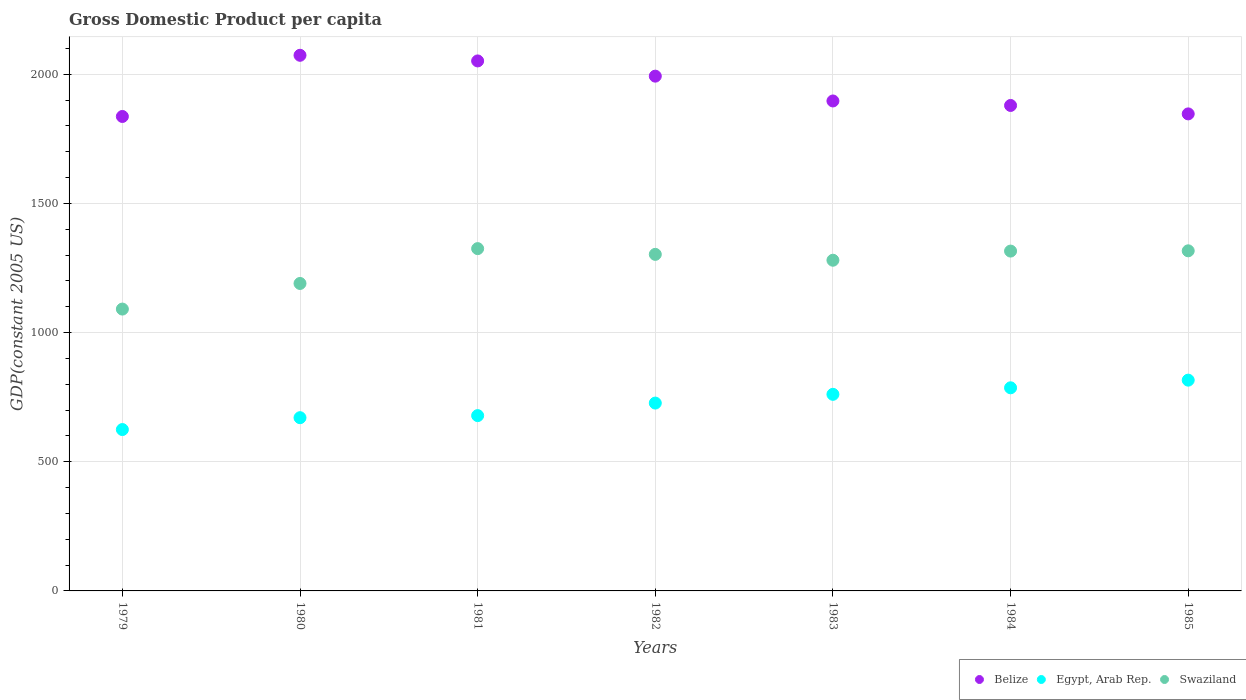How many different coloured dotlines are there?
Your answer should be very brief. 3. What is the GDP per capita in Belize in 1983?
Offer a very short reply. 1896.53. Across all years, what is the maximum GDP per capita in Swaziland?
Give a very brief answer. 1324.99. Across all years, what is the minimum GDP per capita in Egypt, Arab Rep.?
Offer a terse response. 624.63. In which year was the GDP per capita in Swaziland minimum?
Provide a short and direct response. 1979. What is the total GDP per capita in Swaziland in the graph?
Offer a terse response. 8820.86. What is the difference between the GDP per capita in Belize in 1979 and that in 1982?
Make the answer very short. -156.08. What is the difference between the GDP per capita in Swaziland in 1984 and the GDP per capita in Egypt, Arab Rep. in 1979?
Make the answer very short. 690.82. What is the average GDP per capita in Swaziland per year?
Offer a terse response. 1260.12. In the year 1980, what is the difference between the GDP per capita in Belize and GDP per capita in Egypt, Arab Rep.?
Give a very brief answer. 1402.78. What is the ratio of the GDP per capita in Egypt, Arab Rep. in 1980 to that in 1982?
Offer a very short reply. 0.92. Is the GDP per capita in Swaziland in 1982 less than that in 1983?
Make the answer very short. No. What is the difference between the highest and the second highest GDP per capita in Egypt, Arab Rep.?
Keep it short and to the point. 29.63. What is the difference between the highest and the lowest GDP per capita in Swaziland?
Offer a very short reply. 234. Is it the case that in every year, the sum of the GDP per capita in Swaziland and GDP per capita in Belize  is greater than the GDP per capita in Egypt, Arab Rep.?
Provide a short and direct response. Yes. Is the GDP per capita in Egypt, Arab Rep. strictly greater than the GDP per capita in Belize over the years?
Give a very brief answer. No. How many dotlines are there?
Your answer should be very brief. 3. How many years are there in the graph?
Keep it short and to the point. 7. What is the difference between two consecutive major ticks on the Y-axis?
Your answer should be very brief. 500. Are the values on the major ticks of Y-axis written in scientific E-notation?
Offer a terse response. No. Does the graph contain any zero values?
Make the answer very short. No. Does the graph contain grids?
Keep it short and to the point. Yes. How many legend labels are there?
Your answer should be very brief. 3. What is the title of the graph?
Keep it short and to the point. Gross Domestic Product per capita. Does "Papua New Guinea" appear as one of the legend labels in the graph?
Give a very brief answer. No. What is the label or title of the Y-axis?
Your answer should be compact. GDP(constant 2005 US). What is the GDP(constant 2005 US) in Belize in 1979?
Keep it short and to the point. 1836.53. What is the GDP(constant 2005 US) of Egypt, Arab Rep. in 1979?
Keep it short and to the point. 624.63. What is the GDP(constant 2005 US) in Swaziland in 1979?
Your response must be concise. 1090.99. What is the GDP(constant 2005 US) in Belize in 1980?
Your answer should be very brief. 2073.35. What is the GDP(constant 2005 US) of Egypt, Arab Rep. in 1980?
Your answer should be very brief. 670.57. What is the GDP(constant 2005 US) of Swaziland in 1980?
Offer a terse response. 1190.14. What is the GDP(constant 2005 US) in Belize in 1981?
Your response must be concise. 2051.51. What is the GDP(constant 2005 US) in Egypt, Arab Rep. in 1981?
Your answer should be very brief. 678.6. What is the GDP(constant 2005 US) of Swaziland in 1981?
Your answer should be compact. 1324.99. What is the GDP(constant 2005 US) of Belize in 1982?
Offer a terse response. 1992.6. What is the GDP(constant 2005 US) of Egypt, Arab Rep. in 1982?
Offer a very short reply. 727.11. What is the GDP(constant 2005 US) in Swaziland in 1982?
Your answer should be very brief. 1302.75. What is the GDP(constant 2005 US) in Belize in 1983?
Give a very brief answer. 1896.53. What is the GDP(constant 2005 US) in Egypt, Arab Rep. in 1983?
Ensure brevity in your answer.  760.96. What is the GDP(constant 2005 US) in Swaziland in 1983?
Keep it short and to the point. 1280.04. What is the GDP(constant 2005 US) of Belize in 1984?
Provide a short and direct response. 1879.13. What is the GDP(constant 2005 US) in Egypt, Arab Rep. in 1984?
Your answer should be compact. 786.24. What is the GDP(constant 2005 US) of Swaziland in 1984?
Keep it short and to the point. 1315.45. What is the GDP(constant 2005 US) in Belize in 1985?
Your response must be concise. 1846.51. What is the GDP(constant 2005 US) in Egypt, Arab Rep. in 1985?
Your answer should be compact. 815.88. What is the GDP(constant 2005 US) of Swaziland in 1985?
Make the answer very short. 1316.5. Across all years, what is the maximum GDP(constant 2005 US) in Belize?
Your answer should be compact. 2073.35. Across all years, what is the maximum GDP(constant 2005 US) in Egypt, Arab Rep.?
Your response must be concise. 815.88. Across all years, what is the maximum GDP(constant 2005 US) of Swaziland?
Your answer should be very brief. 1324.99. Across all years, what is the minimum GDP(constant 2005 US) of Belize?
Offer a very short reply. 1836.53. Across all years, what is the minimum GDP(constant 2005 US) of Egypt, Arab Rep.?
Provide a short and direct response. 624.63. Across all years, what is the minimum GDP(constant 2005 US) in Swaziland?
Offer a very short reply. 1090.99. What is the total GDP(constant 2005 US) of Belize in the graph?
Your answer should be very brief. 1.36e+04. What is the total GDP(constant 2005 US) in Egypt, Arab Rep. in the graph?
Give a very brief answer. 5063.99. What is the total GDP(constant 2005 US) of Swaziland in the graph?
Your response must be concise. 8820.86. What is the difference between the GDP(constant 2005 US) in Belize in 1979 and that in 1980?
Make the answer very short. -236.82. What is the difference between the GDP(constant 2005 US) in Egypt, Arab Rep. in 1979 and that in 1980?
Make the answer very short. -45.93. What is the difference between the GDP(constant 2005 US) in Swaziland in 1979 and that in 1980?
Offer a terse response. -99.14. What is the difference between the GDP(constant 2005 US) of Belize in 1979 and that in 1981?
Your answer should be very brief. -214.98. What is the difference between the GDP(constant 2005 US) of Egypt, Arab Rep. in 1979 and that in 1981?
Ensure brevity in your answer.  -53.96. What is the difference between the GDP(constant 2005 US) of Swaziland in 1979 and that in 1981?
Offer a very short reply. -234. What is the difference between the GDP(constant 2005 US) in Belize in 1979 and that in 1982?
Offer a very short reply. -156.08. What is the difference between the GDP(constant 2005 US) of Egypt, Arab Rep. in 1979 and that in 1982?
Give a very brief answer. -102.48. What is the difference between the GDP(constant 2005 US) of Swaziland in 1979 and that in 1982?
Offer a terse response. -211.75. What is the difference between the GDP(constant 2005 US) in Belize in 1979 and that in 1983?
Offer a very short reply. -60.01. What is the difference between the GDP(constant 2005 US) of Egypt, Arab Rep. in 1979 and that in 1983?
Provide a short and direct response. -136.33. What is the difference between the GDP(constant 2005 US) of Swaziland in 1979 and that in 1983?
Make the answer very short. -189.05. What is the difference between the GDP(constant 2005 US) of Belize in 1979 and that in 1984?
Your answer should be compact. -42.61. What is the difference between the GDP(constant 2005 US) of Egypt, Arab Rep. in 1979 and that in 1984?
Ensure brevity in your answer.  -161.61. What is the difference between the GDP(constant 2005 US) in Swaziland in 1979 and that in 1984?
Provide a short and direct response. -224.46. What is the difference between the GDP(constant 2005 US) in Belize in 1979 and that in 1985?
Provide a short and direct response. -9.98. What is the difference between the GDP(constant 2005 US) of Egypt, Arab Rep. in 1979 and that in 1985?
Give a very brief answer. -191.24. What is the difference between the GDP(constant 2005 US) in Swaziland in 1979 and that in 1985?
Give a very brief answer. -225.5. What is the difference between the GDP(constant 2005 US) of Belize in 1980 and that in 1981?
Make the answer very short. 21.84. What is the difference between the GDP(constant 2005 US) of Egypt, Arab Rep. in 1980 and that in 1981?
Provide a short and direct response. -8.03. What is the difference between the GDP(constant 2005 US) of Swaziland in 1980 and that in 1981?
Offer a very short reply. -134.86. What is the difference between the GDP(constant 2005 US) of Belize in 1980 and that in 1982?
Give a very brief answer. 80.74. What is the difference between the GDP(constant 2005 US) in Egypt, Arab Rep. in 1980 and that in 1982?
Offer a very short reply. -56.55. What is the difference between the GDP(constant 2005 US) in Swaziland in 1980 and that in 1982?
Keep it short and to the point. -112.61. What is the difference between the GDP(constant 2005 US) in Belize in 1980 and that in 1983?
Offer a very short reply. 176.81. What is the difference between the GDP(constant 2005 US) in Egypt, Arab Rep. in 1980 and that in 1983?
Make the answer very short. -90.39. What is the difference between the GDP(constant 2005 US) in Swaziland in 1980 and that in 1983?
Make the answer very short. -89.91. What is the difference between the GDP(constant 2005 US) in Belize in 1980 and that in 1984?
Offer a very short reply. 194.22. What is the difference between the GDP(constant 2005 US) of Egypt, Arab Rep. in 1980 and that in 1984?
Your response must be concise. -115.68. What is the difference between the GDP(constant 2005 US) of Swaziland in 1980 and that in 1984?
Your response must be concise. -125.32. What is the difference between the GDP(constant 2005 US) of Belize in 1980 and that in 1985?
Your answer should be very brief. 226.84. What is the difference between the GDP(constant 2005 US) in Egypt, Arab Rep. in 1980 and that in 1985?
Your answer should be compact. -145.31. What is the difference between the GDP(constant 2005 US) in Swaziland in 1980 and that in 1985?
Give a very brief answer. -126.36. What is the difference between the GDP(constant 2005 US) of Belize in 1981 and that in 1982?
Offer a terse response. 58.9. What is the difference between the GDP(constant 2005 US) of Egypt, Arab Rep. in 1981 and that in 1982?
Your response must be concise. -48.51. What is the difference between the GDP(constant 2005 US) of Swaziland in 1981 and that in 1982?
Make the answer very short. 22.25. What is the difference between the GDP(constant 2005 US) of Belize in 1981 and that in 1983?
Give a very brief answer. 154.97. What is the difference between the GDP(constant 2005 US) of Egypt, Arab Rep. in 1981 and that in 1983?
Give a very brief answer. -82.36. What is the difference between the GDP(constant 2005 US) in Swaziland in 1981 and that in 1983?
Offer a very short reply. 44.95. What is the difference between the GDP(constant 2005 US) of Belize in 1981 and that in 1984?
Offer a very short reply. 172.37. What is the difference between the GDP(constant 2005 US) in Egypt, Arab Rep. in 1981 and that in 1984?
Provide a succinct answer. -107.65. What is the difference between the GDP(constant 2005 US) of Swaziland in 1981 and that in 1984?
Keep it short and to the point. 9.54. What is the difference between the GDP(constant 2005 US) of Belize in 1981 and that in 1985?
Your response must be concise. 205. What is the difference between the GDP(constant 2005 US) in Egypt, Arab Rep. in 1981 and that in 1985?
Your answer should be very brief. -137.28. What is the difference between the GDP(constant 2005 US) of Swaziland in 1981 and that in 1985?
Your answer should be very brief. 8.5. What is the difference between the GDP(constant 2005 US) in Belize in 1982 and that in 1983?
Give a very brief answer. 96.07. What is the difference between the GDP(constant 2005 US) of Egypt, Arab Rep. in 1982 and that in 1983?
Offer a very short reply. -33.85. What is the difference between the GDP(constant 2005 US) of Swaziland in 1982 and that in 1983?
Offer a very short reply. 22.7. What is the difference between the GDP(constant 2005 US) in Belize in 1982 and that in 1984?
Your answer should be compact. 113.47. What is the difference between the GDP(constant 2005 US) in Egypt, Arab Rep. in 1982 and that in 1984?
Provide a short and direct response. -59.13. What is the difference between the GDP(constant 2005 US) in Swaziland in 1982 and that in 1984?
Offer a very short reply. -12.71. What is the difference between the GDP(constant 2005 US) of Belize in 1982 and that in 1985?
Provide a succinct answer. 146.1. What is the difference between the GDP(constant 2005 US) in Egypt, Arab Rep. in 1982 and that in 1985?
Offer a terse response. -88.76. What is the difference between the GDP(constant 2005 US) in Swaziland in 1982 and that in 1985?
Keep it short and to the point. -13.75. What is the difference between the GDP(constant 2005 US) of Belize in 1983 and that in 1984?
Your answer should be very brief. 17.4. What is the difference between the GDP(constant 2005 US) of Egypt, Arab Rep. in 1983 and that in 1984?
Make the answer very short. -25.28. What is the difference between the GDP(constant 2005 US) of Swaziland in 1983 and that in 1984?
Your answer should be very brief. -35.41. What is the difference between the GDP(constant 2005 US) in Belize in 1983 and that in 1985?
Provide a short and direct response. 50.03. What is the difference between the GDP(constant 2005 US) of Egypt, Arab Rep. in 1983 and that in 1985?
Your answer should be very brief. -54.92. What is the difference between the GDP(constant 2005 US) of Swaziland in 1983 and that in 1985?
Offer a very short reply. -36.45. What is the difference between the GDP(constant 2005 US) in Belize in 1984 and that in 1985?
Ensure brevity in your answer.  32.63. What is the difference between the GDP(constant 2005 US) in Egypt, Arab Rep. in 1984 and that in 1985?
Your answer should be very brief. -29.63. What is the difference between the GDP(constant 2005 US) in Swaziland in 1984 and that in 1985?
Offer a very short reply. -1.04. What is the difference between the GDP(constant 2005 US) in Belize in 1979 and the GDP(constant 2005 US) in Egypt, Arab Rep. in 1980?
Offer a terse response. 1165.96. What is the difference between the GDP(constant 2005 US) of Belize in 1979 and the GDP(constant 2005 US) of Swaziland in 1980?
Keep it short and to the point. 646.39. What is the difference between the GDP(constant 2005 US) in Egypt, Arab Rep. in 1979 and the GDP(constant 2005 US) in Swaziland in 1980?
Keep it short and to the point. -565.5. What is the difference between the GDP(constant 2005 US) of Belize in 1979 and the GDP(constant 2005 US) of Egypt, Arab Rep. in 1981?
Your response must be concise. 1157.93. What is the difference between the GDP(constant 2005 US) of Belize in 1979 and the GDP(constant 2005 US) of Swaziland in 1981?
Offer a terse response. 511.53. What is the difference between the GDP(constant 2005 US) in Egypt, Arab Rep. in 1979 and the GDP(constant 2005 US) in Swaziland in 1981?
Your answer should be compact. -700.36. What is the difference between the GDP(constant 2005 US) in Belize in 1979 and the GDP(constant 2005 US) in Egypt, Arab Rep. in 1982?
Provide a short and direct response. 1109.41. What is the difference between the GDP(constant 2005 US) of Belize in 1979 and the GDP(constant 2005 US) of Swaziland in 1982?
Provide a short and direct response. 533.78. What is the difference between the GDP(constant 2005 US) in Egypt, Arab Rep. in 1979 and the GDP(constant 2005 US) in Swaziland in 1982?
Provide a short and direct response. -678.11. What is the difference between the GDP(constant 2005 US) of Belize in 1979 and the GDP(constant 2005 US) of Egypt, Arab Rep. in 1983?
Offer a very short reply. 1075.57. What is the difference between the GDP(constant 2005 US) in Belize in 1979 and the GDP(constant 2005 US) in Swaziland in 1983?
Offer a very short reply. 556.48. What is the difference between the GDP(constant 2005 US) of Egypt, Arab Rep. in 1979 and the GDP(constant 2005 US) of Swaziland in 1983?
Offer a very short reply. -655.41. What is the difference between the GDP(constant 2005 US) of Belize in 1979 and the GDP(constant 2005 US) of Egypt, Arab Rep. in 1984?
Offer a very short reply. 1050.28. What is the difference between the GDP(constant 2005 US) in Belize in 1979 and the GDP(constant 2005 US) in Swaziland in 1984?
Offer a terse response. 521.07. What is the difference between the GDP(constant 2005 US) of Egypt, Arab Rep. in 1979 and the GDP(constant 2005 US) of Swaziland in 1984?
Provide a short and direct response. -690.82. What is the difference between the GDP(constant 2005 US) of Belize in 1979 and the GDP(constant 2005 US) of Egypt, Arab Rep. in 1985?
Keep it short and to the point. 1020.65. What is the difference between the GDP(constant 2005 US) in Belize in 1979 and the GDP(constant 2005 US) in Swaziland in 1985?
Give a very brief answer. 520.03. What is the difference between the GDP(constant 2005 US) in Egypt, Arab Rep. in 1979 and the GDP(constant 2005 US) in Swaziland in 1985?
Give a very brief answer. -691.86. What is the difference between the GDP(constant 2005 US) of Belize in 1980 and the GDP(constant 2005 US) of Egypt, Arab Rep. in 1981?
Your response must be concise. 1394.75. What is the difference between the GDP(constant 2005 US) of Belize in 1980 and the GDP(constant 2005 US) of Swaziland in 1981?
Provide a short and direct response. 748.36. What is the difference between the GDP(constant 2005 US) of Egypt, Arab Rep. in 1980 and the GDP(constant 2005 US) of Swaziland in 1981?
Your answer should be very brief. -654.43. What is the difference between the GDP(constant 2005 US) in Belize in 1980 and the GDP(constant 2005 US) in Egypt, Arab Rep. in 1982?
Keep it short and to the point. 1346.24. What is the difference between the GDP(constant 2005 US) in Belize in 1980 and the GDP(constant 2005 US) in Swaziland in 1982?
Provide a succinct answer. 770.6. What is the difference between the GDP(constant 2005 US) of Egypt, Arab Rep. in 1980 and the GDP(constant 2005 US) of Swaziland in 1982?
Provide a short and direct response. -632.18. What is the difference between the GDP(constant 2005 US) in Belize in 1980 and the GDP(constant 2005 US) in Egypt, Arab Rep. in 1983?
Your answer should be very brief. 1312.39. What is the difference between the GDP(constant 2005 US) of Belize in 1980 and the GDP(constant 2005 US) of Swaziland in 1983?
Your answer should be compact. 793.31. What is the difference between the GDP(constant 2005 US) in Egypt, Arab Rep. in 1980 and the GDP(constant 2005 US) in Swaziland in 1983?
Provide a short and direct response. -609.48. What is the difference between the GDP(constant 2005 US) in Belize in 1980 and the GDP(constant 2005 US) in Egypt, Arab Rep. in 1984?
Ensure brevity in your answer.  1287.11. What is the difference between the GDP(constant 2005 US) in Belize in 1980 and the GDP(constant 2005 US) in Swaziland in 1984?
Give a very brief answer. 757.9. What is the difference between the GDP(constant 2005 US) of Egypt, Arab Rep. in 1980 and the GDP(constant 2005 US) of Swaziland in 1984?
Offer a very short reply. -644.89. What is the difference between the GDP(constant 2005 US) of Belize in 1980 and the GDP(constant 2005 US) of Egypt, Arab Rep. in 1985?
Ensure brevity in your answer.  1257.47. What is the difference between the GDP(constant 2005 US) of Belize in 1980 and the GDP(constant 2005 US) of Swaziland in 1985?
Your answer should be compact. 756.85. What is the difference between the GDP(constant 2005 US) in Egypt, Arab Rep. in 1980 and the GDP(constant 2005 US) in Swaziland in 1985?
Provide a short and direct response. -645.93. What is the difference between the GDP(constant 2005 US) in Belize in 1981 and the GDP(constant 2005 US) in Egypt, Arab Rep. in 1982?
Make the answer very short. 1324.4. What is the difference between the GDP(constant 2005 US) in Belize in 1981 and the GDP(constant 2005 US) in Swaziland in 1982?
Provide a succinct answer. 748.76. What is the difference between the GDP(constant 2005 US) of Egypt, Arab Rep. in 1981 and the GDP(constant 2005 US) of Swaziland in 1982?
Provide a short and direct response. -624.15. What is the difference between the GDP(constant 2005 US) of Belize in 1981 and the GDP(constant 2005 US) of Egypt, Arab Rep. in 1983?
Ensure brevity in your answer.  1290.55. What is the difference between the GDP(constant 2005 US) of Belize in 1981 and the GDP(constant 2005 US) of Swaziland in 1983?
Your response must be concise. 771.46. What is the difference between the GDP(constant 2005 US) of Egypt, Arab Rep. in 1981 and the GDP(constant 2005 US) of Swaziland in 1983?
Give a very brief answer. -601.45. What is the difference between the GDP(constant 2005 US) in Belize in 1981 and the GDP(constant 2005 US) in Egypt, Arab Rep. in 1984?
Give a very brief answer. 1265.26. What is the difference between the GDP(constant 2005 US) of Belize in 1981 and the GDP(constant 2005 US) of Swaziland in 1984?
Offer a very short reply. 736.05. What is the difference between the GDP(constant 2005 US) in Egypt, Arab Rep. in 1981 and the GDP(constant 2005 US) in Swaziland in 1984?
Make the answer very short. -636.86. What is the difference between the GDP(constant 2005 US) of Belize in 1981 and the GDP(constant 2005 US) of Egypt, Arab Rep. in 1985?
Provide a short and direct response. 1235.63. What is the difference between the GDP(constant 2005 US) in Belize in 1981 and the GDP(constant 2005 US) in Swaziland in 1985?
Make the answer very short. 735.01. What is the difference between the GDP(constant 2005 US) of Egypt, Arab Rep. in 1981 and the GDP(constant 2005 US) of Swaziland in 1985?
Offer a terse response. -637.9. What is the difference between the GDP(constant 2005 US) in Belize in 1982 and the GDP(constant 2005 US) in Egypt, Arab Rep. in 1983?
Make the answer very short. 1231.64. What is the difference between the GDP(constant 2005 US) of Belize in 1982 and the GDP(constant 2005 US) of Swaziland in 1983?
Offer a terse response. 712.56. What is the difference between the GDP(constant 2005 US) in Egypt, Arab Rep. in 1982 and the GDP(constant 2005 US) in Swaziland in 1983?
Keep it short and to the point. -552.93. What is the difference between the GDP(constant 2005 US) in Belize in 1982 and the GDP(constant 2005 US) in Egypt, Arab Rep. in 1984?
Offer a very short reply. 1206.36. What is the difference between the GDP(constant 2005 US) of Belize in 1982 and the GDP(constant 2005 US) of Swaziland in 1984?
Ensure brevity in your answer.  677.15. What is the difference between the GDP(constant 2005 US) in Egypt, Arab Rep. in 1982 and the GDP(constant 2005 US) in Swaziland in 1984?
Provide a succinct answer. -588.34. What is the difference between the GDP(constant 2005 US) of Belize in 1982 and the GDP(constant 2005 US) of Egypt, Arab Rep. in 1985?
Keep it short and to the point. 1176.73. What is the difference between the GDP(constant 2005 US) in Belize in 1982 and the GDP(constant 2005 US) in Swaziland in 1985?
Make the answer very short. 676.11. What is the difference between the GDP(constant 2005 US) in Egypt, Arab Rep. in 1982 and the GDP(constant 2005 US) in Swaziland in 1985?
Give a very brief answer. -589.38. What is the difference between the GDP(constant 2005 US) in Belize in 1983 and the GDP(constant 2005 US) in Egypt, Arab Rep. in 1984?
Your answer should be very brief. 1110.29. What is the difference between the GDP(constant 2005 US) in Belize in 1983 and the GDP(constant 2005 US) in Swaziland in 1984?
Provide a succinct answer. 581.08. What is the difference between the GDP(constant 2005 US) in Egypt, Arab Rep. in 1983 and the GDP(constant 2005 US) in Swaziland in 1984?
Provide a succinct answer. -554.49. What is the difference between the GDP(constant 2005 US) of Belize in 1983 and the GDP(constant 2005 US) of Egypt, Arab Rep. in 1985?
Your response must be concise. 1080.66. What is the difference between the GDP(constant 2005 US) of Belize in 1983 and the GDP(constant 2005 US) of Swaziland in 1985?
Make the answer very short. 580.04. What is the difference between the GDP(constant 2005 US) of Egypt, Arab Rep. in 1983 and the GDP(constant 2005 US) of Swaziland in 1985?
Keep it short and to the point. -555.54. What is the difference between the GDP(constant 2005 US) in Belize in 1984 and the GDP(constant 2005 US) in Egypt, Arab Rep. in 1985?
Offer a terse response. 1063.26. What is the difference between the GDP(constant 2005 US) of Belize in 1984 and the GDP(constant 2005 US) of Swaziland in 1985?
Ensure brevity in your answer.  562.64. What is the difference between the GDP(constant 2005 US) of Egypt, Arab Rep. in 1984 and the GDP(constant 2005 US) of Swaziland in 1985?
Your answer should be compact. -530.25. What is the average GDP(constant 2005 US) of Belize per year?
Provide a succinct answer. 1939.45. What is the average GDP(constant 2005 US) of Egypt, Arab Rep. per year?
Provide a short and direct response. 723.43. What is the average GDP(constant 2005 US) in Swaziland per year?
Provide a succinct answer. 1260.12. In the year 1979, what is the difference between the GDP(constant 2005 US) in Belize and GDP(constant 2005 US) in Egypt, Arab Rep.?
Offer a very short reply. 1211.89. In the year 1979, what is the difference between the GDP(constant 2005 US) of Belize and GDP(constant 2005 US) of Swaziland?
Offer a terse response. 745.53. In the year 1979, what is the difference between the GDP(constant 2005 US) in Egypt, Arab Rep. and GDP(constant 2005 US) in Swaziland?
Provide a succinct answer. -466.36. In the year 1980, what is the difference between the GDP(constant 2005 US) of Belize and GDP(constant 2005 US) of Egypt, Arab Rep.?
Make the answer very short. 1402.78. In the year 1980, what is the difference between the GDP(constant 2005 US) in Belize and GDP(constant 2005 US) in Swaziland?
Make the answer very short. 883.21. In the year 1980, what is the difference between the GDP(constant 2005 US) in Egypt, Arab Rep. and GDP(constant 2005 US) in Swaziland?
Your response must be concise. -519.57. In the year 1981, what is the difference between the GDP(constant 2005 US) in Belize and GDP(constant 2005 US) in Egypt, Arab Rep.?
Give a very brief answer. 1372.91. In the year 1981, what is the difference between the GDP(constant 2005 US) of Belize and GDP(constant 2005 US) of Swaziland?
Ensure brevity in your answer.  726.52. In the year 1981, what is the difference between the GDP(constant 2005 US) of Egypt, Arab Rep. and GDP(constant 2005 US) of Swaziland?
Offer a terse response. -646.39. In the year 1982, what is the difference between the GDP(constant 2005 US) in Belize and GDP(constant 2005 US) in Egypt, Arab Rep.?
Your answer should be compact. 1265.49. In the year 1982, what is the difference between the GDP(constant 2005 US) of Belize and GDP(constant 2005 US) of Swaziland?
Your answer should be very brief. 689.86. In the year 1982, what is the difference between the GDP(constant 2005 US) in Egypt, Arab Rep. and GDP(constant 2005 US) in Swaziland?
Offer a terse response. -575.64. In the year 1983, what is the difference between the GDP(constant 2005 US) in Belize and GDP(constant 2005 US) in Egypt, Arab Rep.?
Provide a short and direct response. 1135.58. In the year 1983, what is the difference between the GDP(constant 2005 US) of Belize and GDP(constant 2005 US) of Swaziland?
Give a very brief answer. 616.49. In the year 1983, what is the difference between the GDP(constant 2005 US) in Egypt, Arab Rep. and GDP(constant 2005 US) in Swaziland?
Provide a short and direct response. -519.08. In the year 1984, what is the difference between the GDP(constant 2005 US) in Belize and GDP(constant 2005 US) in Egypt, Arab Rep.?
Your answer should be compact. 1092.89. In the year 1984, what is the difference between the GDP(constant 2005 US) of Belize and GDP(constant 2005 US) of Swaziland?
Offer a very short reply. 563.68. In the year 1984, what is the difference between the GDP(constant 2005 US) in Egypt, Arab Rep. and GDP(constant 2005 US) in Swaziland?
Provide a short and direct response. -529.21. In the year 1985, what is the difference between the GDP(constant 2005 US) of Belize and GDP(constant 2005 US) of Egypt, Arab Rep.?
Ensure brevity in your answer.  1030.63. In the year 1985, what is the difference between the GDP(constant 2005 US) in Belize and GDP(constant 2005 US) in Swaziland?
Ensure brevity in your answer.  530.01. In the year 1985, what is the difference between the GDP(constant 2005 US) in Egypt, Arab Rep. and GDP(constant 2005 US) in Swaziland?
Give a very brief answer. -500.62. What is the ratio of the GDP(constant 2005 US) in Belize in 1979 to that in 1980?
Offer a very short reply. 0.89. What is the ratio of the GDP(constant 2005 US) of Egypt, Arab Rep. in 1979 to that in 1980?
Your answer should be very brief. 0.93. What is the ratio of the GDP(constant 2005 US) of Belize in 1979 to that in 1981?
Provide a short and direct response. 0.9. What is the ratio of the GDP(constant 2005 US) in Egypt, Arab Rep. in 1979 to that in 1981?
Make the answer very short. 0.92. What is the ratio of the GDP(constant 2005 US) of Swaziland in 1979 to that in 1981?
Give a very brief answer. 0.82. What is the ratio of the GDP(constant 2005 US) in Belize in 1979 to that in 1982?
Provide a succinct answer. 0.92. What is the ratio of the GDP(constant 2005 US) of Egypt, Arab Rep. in 1979 to that in 1982?
Your answer should be very brief. 0.86. What is the ratio of the GDP(constant 2005 US) in Swaziland in 1979 to that in 1982?
Keep it short and to the point. 0.84. What is the ratio of the GDP(constant 2005 US) of Belize in 1979 to that in 1983?
Ensure brevity in your answer.  0.97. What is the ratio of the GDP(constant 2005 US) of Egypt, Arab Rep. in 1979 to that in 1983?
Keep it short and to the point. 0.82. What is the ratio of the GDP(constant 2005 US) in Swaziland in 1979 to that in 1983?
Provide a short and direct response. 0.85. What is the ratio of the GDP(constant 2005 US) in Belize in 1979 to that in 1984?
Your answer should be compact. 0.98. What is the ratio of the GDP(constant 2005 US) in Egypt, Arab Rep. in 1979 to that in 1984?
Your answer should be compact. 0.79. What is the ratio of the GDP(constant 2005 US) in Swaziland in 1979 to that in 1984?
Your response must be concise. 0.83. What is the ratio of the GDP(constant 2005 US) in Belize in 1979 to that in 1985?
Provide a succinct answer. 0.99. What is the ratio of the GDP(constant 2005 US) of Egypt, Arab Rep. in 1979 to that in 1985?
Make the answer very short. 0.77. What is the ratio of the GDP(constant 2005 US) of Swaziland in 1979 to that in 1985?
Provide a succinct answer. 0.83. What is the ratio of the GDP(constant 2005 US) in Belize in 1980 to that in 1981?
Give a very brief answer. 1.01. What is the ratio of the GDP(constant 2005 US) of Egypt, Arab Rep. in 1980 to that in 1981?
Your answer should be compact. 0.99. What is the ratio of the GDP(constant 2005 US) in Swaziland in 1980 to that in 1981?
Ensure brevity in your answer.  0.9. What is the ratio of the GDP(constant 2005 US) of Belize in 1980 to that in 1982?
Offer a terse response. 1.04. What is the ratio of the GDP(constant 2005 US) in Egypt, Arab Rep. in 1980 to that in 1982?
Your response must be concise. 0.92. What is the ratio of the GDP(constant 2005 US) of Swaziland in 1980 to that in 1982?
Offer a very short reply. 0.91. What is the ratio of the GDP(constant 2005 US) in Belize in 1980 to that in 1983?
Offer a terse response. 1.09. What is the ratio of the GDP(constant 2005 US) in Egypt, Arab Rep. in 1980 to that in 1983?
Keep it short and to the point. 0.88. What is the ratio of the GDP(constant 2005 US) in Swaziland in 1980 to that in 1983?
Make the answer very short. 0.93. What is the ratio of the GDP(constant 2005 US) of Belize in 1980 to that in 1984?
Provide a short and direct response. 1.1. What is the ratio of the GDP(constant 2005 US) in Egypt, Arab Rep. in 1980 to that in 1984?
Your answer should be very brief. 0.85. What is the ratio of the GDP(constant 2005 US) of Swaziland in 1980 to that in 1984?
Your response must be concise. 0.9. What is the ratio of the GDP(constant 2005 US) of Belize in 1980 to that in 1985?
Provide a short and direct response. 1.12. What is the ratio of the GDP(constant 2005 US) in Egypt, Arab Rep. in 1980 to that in 1985?
Provide a succinct answer. 0.82. What is the ratio of the GDP(constant 2005 US) in Swaziland in 1980 to that in 1985?
Your answer should be very brief. 0.9. What is the ratio of the GDP(constant 2005 US) in Belize in 1981 to that in 1982?
Offer a very short reply. 1.03. What is the ratio of the GDP(constant 2005 US) of Egypt, Arab Rep. in 1981 to that in 1982?
Keep it short and to the point. 0.93. What is the ratio of the GDP(constant 2005 US) of Swaziland in 1981 to that in 1982?
Provide a short and direct response. 1.02. What is the ratio of the GDP(constant 2005 US) in Belize in 1981 to that in 1983?
Keep it short and to the point. 1.08. What is the ratio of the GDP(constant 2005 US) of Egypt, Arab Rep. in 1981 to that in 1983?
Make the answer very short. 0.89. What is the ratio of the GDP(constant 2005 US) of Swaziland in 1981 to that in 1983?
Ensure brevity in your answer.  1.04. What is the ratio of the GDP(constant 2005 US) of Belize in 1981 to that in 1984?
Ensure brevity in your answer.  1.09. What is the ratio of the GDP(constant 2005 US) in Egypt, Arab Rep. in 1981 to that in 1984?
Your answer should be compact. 0.86. What is the ratio of the GDP(constant 2005 US) in Swaziland in 1981 to that in 1984?
Make the answer very short. 1.01. What is the ratio of the GDP(constant 2005 US) of Belize in 1981 to that in 1985?
Your answer should be compact. 1.11. What is the ratio of the GDP(constant 2005 US) of Egypt, Arab Rep. in 1981 to that in 1985?
Provide a succinct answer. 0.83. What is the ratio of the GDP(constant 2005 US) in Swaziland in 1981 to that in 1985?
Give a very brief answer. 1.01. What is the ratio of the GDP(constant 2005 US) in Belize in 1982 to that in 1983?
Your answer should be very brief. 1.05. What is the ratio of the GDP(constant 2005 US) in Egypt, Arab Rep. in 1982 to that in 1983?
Provide a short and direct response. 0.96. What is the ratio of the GDP(constant 2005 US) in Swaziland in 1982 to that in 1983?
Ensure brevity in your answer.  1.02. What is the ratio of the GDP(constant 2005 US) of Belize in 1982 to that in 1984?
Your response must be concise. 1.06. What is the ratio of the GDP(constant 2005 US) in Egypt, Arab Rep. in 1982 to that in 1984?
Offer a very short reply. 0.92. What is the ratio of the GDP(constant 2005 US) in Swaziland in 1982 to that in 1984?
Make the answer very short. 0.99. What is the ratio of the GDP(constant 2005 US) of Belize in 1982 to that in 1985?
Your response must be concise. 1.08. What is the ratio of the GDP(constant 2005 US) in Egypt, Arab Rep. in 1982 to that in 1985?
Your answer should be compact. 0.89. What is the ratio of the GDP(constant 2005 US) of Belize in 1983 to that in 1984?
Your answer should be very brief. 1.01. What is the ratio of the GDP(constant 2005 US) of Egypt, Arab Rep. in 1983 to that in 1984?
Offer a very short reply. 0.97. What is the ratio of the GDP(constant 2005 US) of Swaziland in 1983 to that in 1984?
Ensure brevity in your answer.  0.97. What is the ratio of the GDP(constant 2005 US) of Belize in 1983 to that in 1985?
Make the answer very short. 1.03. What is the ratio of the GDP(constant 2005 US) of Egypt, Arab Rep. in 1983 to that in 1985?
Provide a short and direct response. 0.93. What is the ratio of the GDP(constant 2005 US) of Swaziland in 1983 to that in 1985?
Your response must be concise. 0.97. What is the ratio of the GDP(constant 2005 US) in Belize in 1984 to that in 1985?
Offer a terse response. 1.02. What is the ratio of the GDP(constant 2005 US) in Egypt, Arab Rep. in 1984 to that in 1985?
Your answer should be very brief. 0.96. What is the ratio of the GDP(constant 2005 US) in Swaziland in 1984 to that in 1985?
Make the answer very short. 1. What is the difference between the highest and the second highest GDP(constant 2005 US) in Belize?
Offer a terse response. 21.84. What is the difference between the highest and the second highest GDP(constant 2005 US) of Egypt, Arab Rep.?
Keep it short and to the point. 29.63. What is the difference between the highest and the second highest GDP(constant 2005 US) in Swaziland?
Ensure brevity in your answer.  8.5. What is the difference between the highest and the lowest GDP(constant 2005 US) in Belize?
Keep it short and to the point. 236.82. What is the difference between the highest and the lowest GDP(constant 2005 US) in Egypt, Arab Rep.?
Keep it short and to the point. 191.24. What is the difference between the highest and the lowest GDP(constant 2005 US) in Swaziland?
Offer a terse response. 234. 